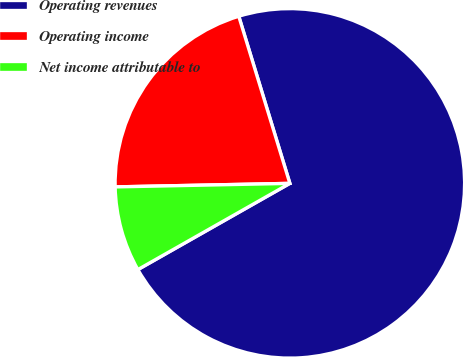Convert chart to OTSL. <chart><loc_0><loc_0><loc_500><loc_500><pie_chart><fcel>Operating revenues<fcel>Operating income<fcel>Net income attributable to<nl><fcel>71.51%<fcel>20.6%<fcel>7.89%<nl></chart> 